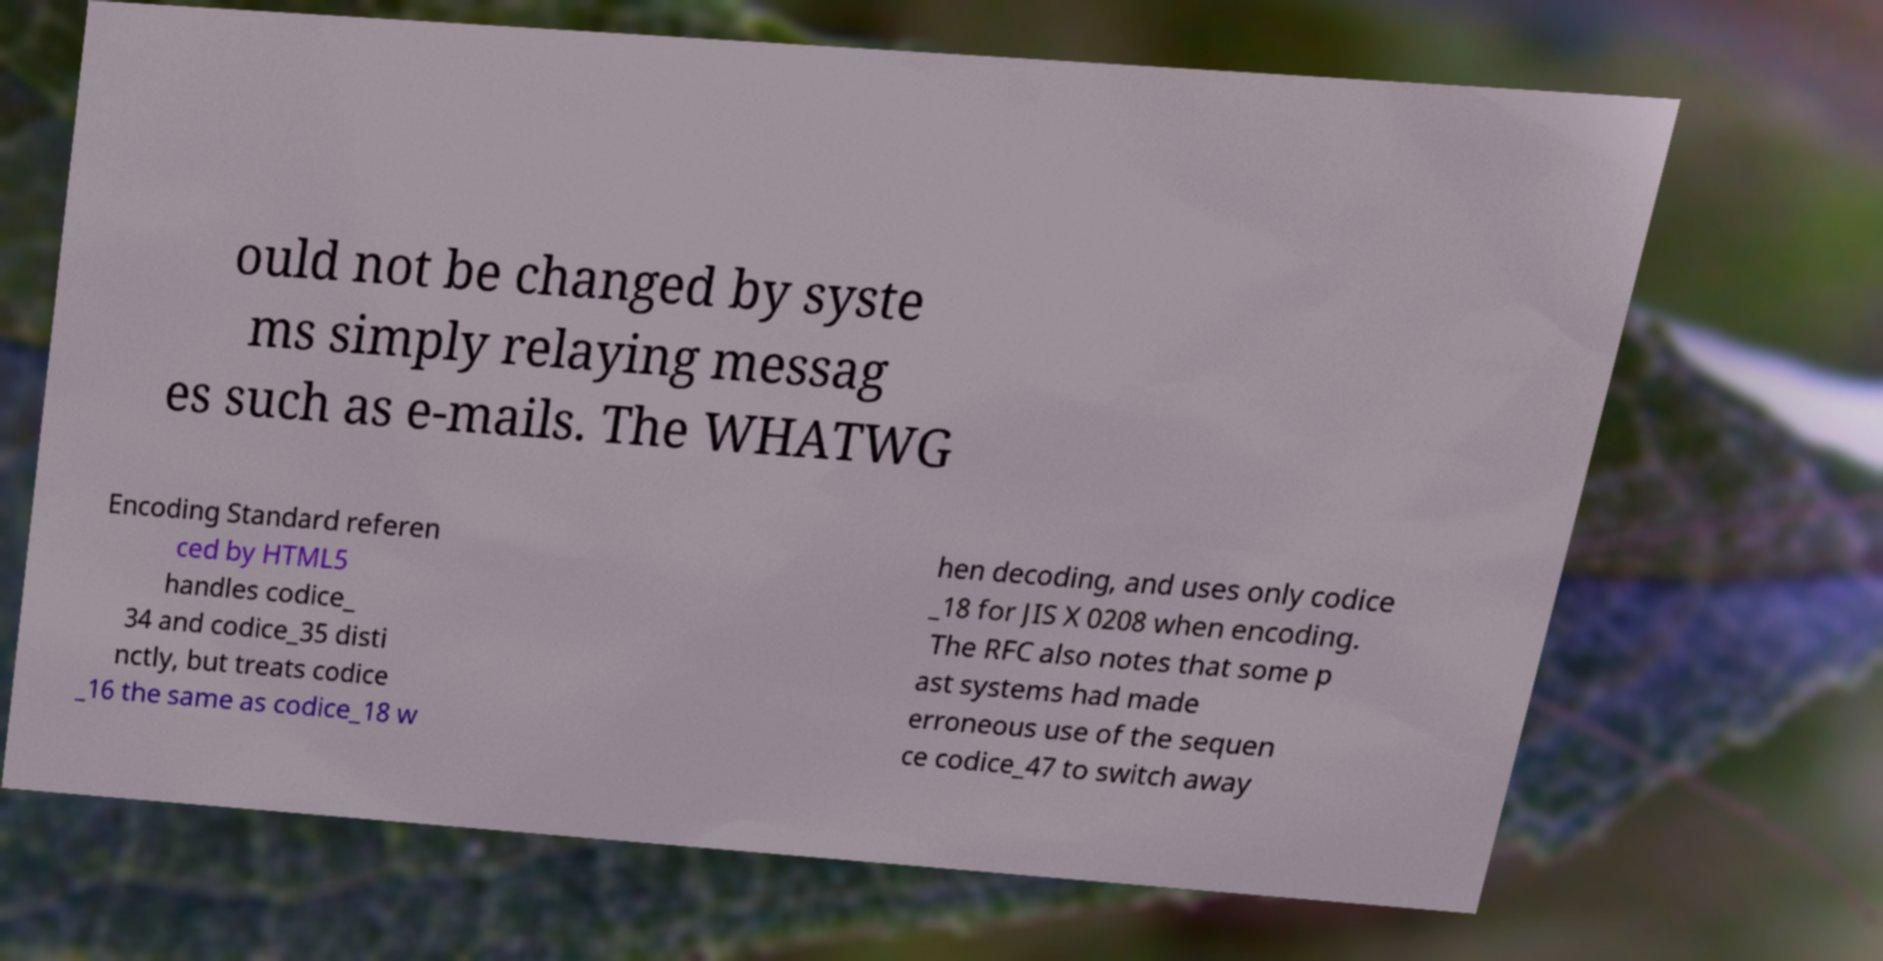What messages or text are displayed in this image? I need them in a readable, typed format. ould not be changed by syste ms simply relaying messag es such as e-mails. The WHATWG Encoding Standard referen ced by HTML5 handles codice_ 34 and codice_35 disti nctly, but treats codice _16 the same as codice_18 w hen decoding, and uses only codice _18 for JIS X 0208 when encoding. The RFC also notes that some p ast systems had made erroneous use of the sequen ce codice_47 to switch away 